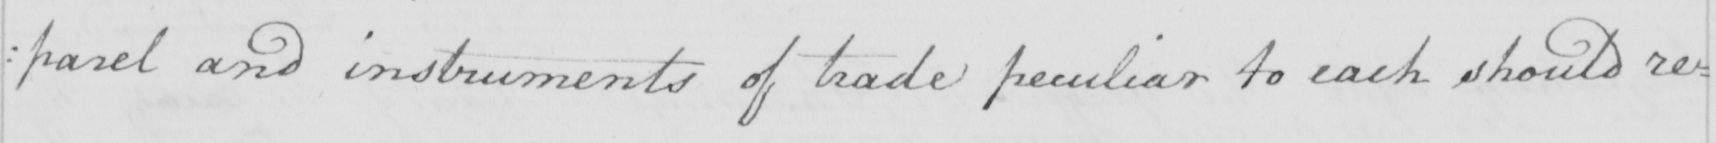Transcribe the text shown in this historical manuscript line. : parel and instruments of trade peculiar to each should re= 